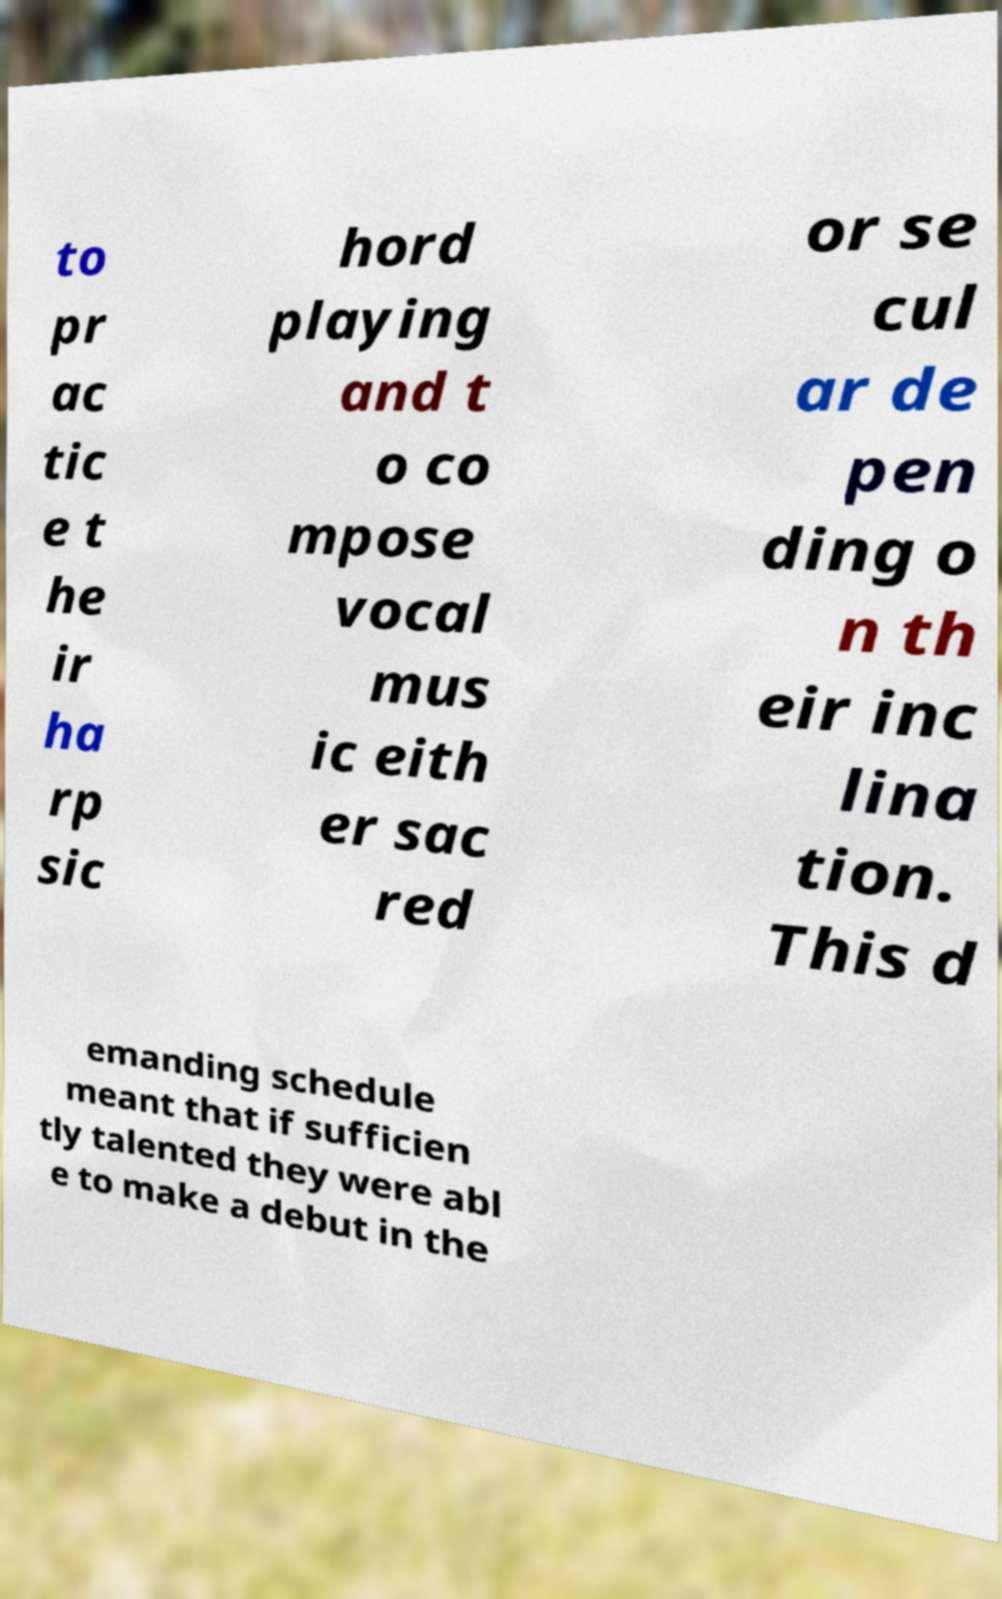Please read and relay the text visible in this image. What does it say? to pr ac tic e t he ir ha rp sic hord playing and t o co mpose vocal mus ic eith er sac red or se cul ar de pen ding o n th eir inc lina tion. This d emanding schedule meant that if sufficien tly talented they were abl e to make a debut in the 